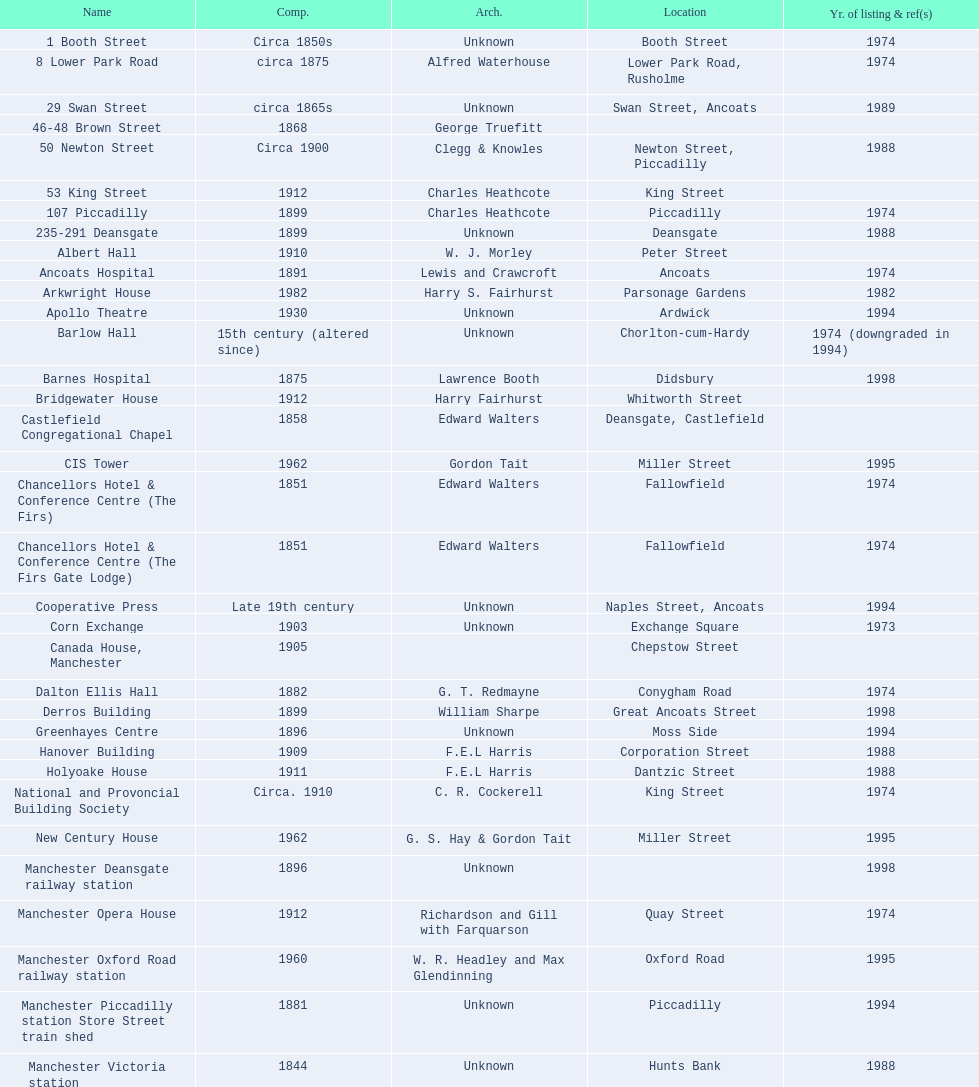Was charles heathcote the architect of ancoats hospital and apollo theatre? No. 